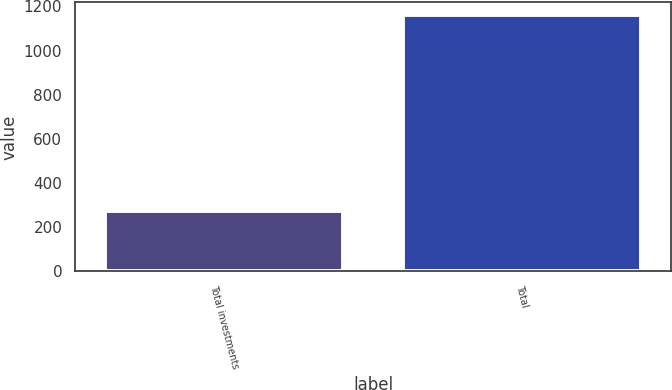<chart> <loc_0><loc_0><loc_500><loc_500><bar_chart><fcel>Total investments<fcel>Total<nl><fcel>273<fcel>1160<nl></chart> 